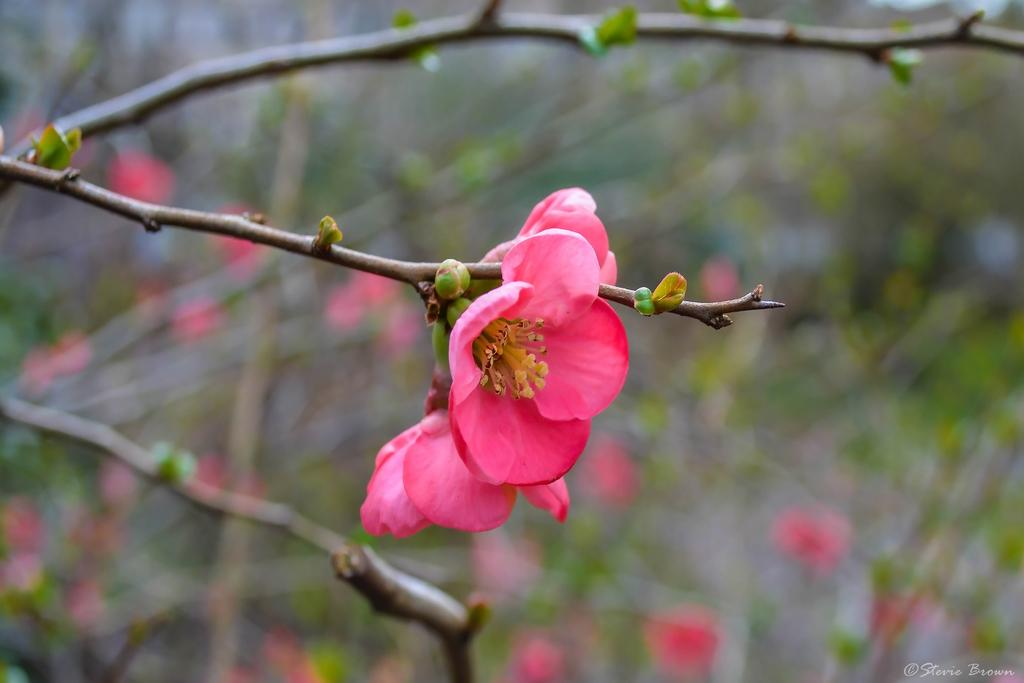What is the main subject of the picture? The main subject of the picture is a plant. What color are the flowers on the plant? The flowers on the plant are pink. How would you describe the background of the image? The background of the image is blurred. Is there any additional information or markings on the image? Yes, there is a watermark on the image. How many houses can be seen in the background of the image? There are no houses visible in the image; the background is blurred and only features the plant with pink flowers. What type of spot is present on the plant in the image? There is no spot present on the plant in the image; it has pink flowers and a blurred background. 